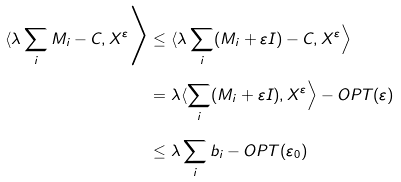Convert formula to latex. <formula><loc_0><loc_0><loc_500><loc_500>\langle \lambda \sum _ { i } M _ { i } - C , X ^ { \varepsilon } \Big \rangle & \leq \langle \lambda \sum _ { i } ( M _ { i } + \varepsilon I ) - C , X ^ { \varepsilon } \Big \rangle \\ & = \lambda \langle \sum _ { i } ( M _ { i } + \varepsilon I ) , X ^ { \varepsilon } \Big \rangle - O P T ( \varepsilon ) \\ & \leq \lambda \sum _ { i } b _ { i } - O P T ( \varepsilon _ { 0 } )</formula> 